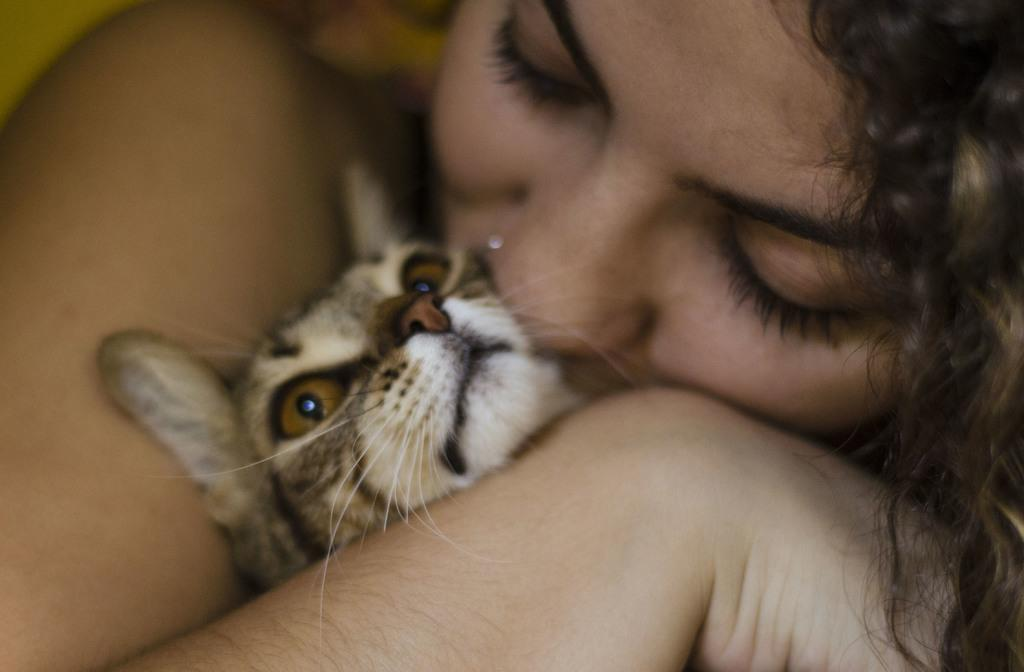Who is present in the image? There is a woman in the image. What else can be seen in the image? There is a kitten in the image. What is the woman doing with the kitten? The woman is kissing the kitten. What type of furniture is visible in the image? There is no furniture visible in the image; it only features a woman and a kitten. Can you tell me how many buttons are on the kitten's collar in the image? The kitten in the image is not wearing a collar, so there are no buttons to count. 